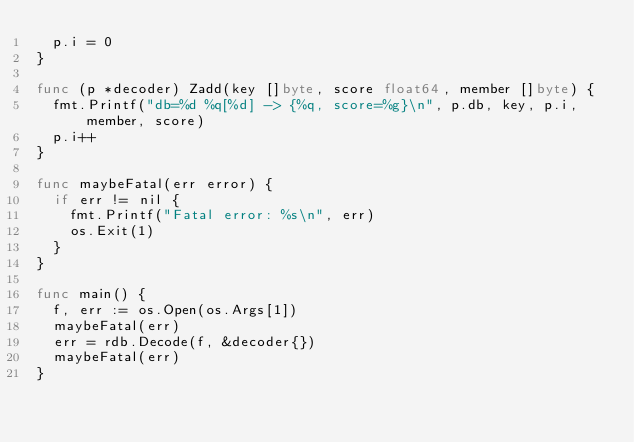Convert code to text. <code><loc_0><loc_0><loc_500><loc_500><_Go_>	p.i = 0
}

func (p *decoder) Zadd(key []byte, score float64, member []byte) {
	fmt.Printf("db=%d %q[%d] -> {%q, score=%g}\n", p.db, key, p.i, member, score)
	p.i++
}

func maybeFatal(err error) {
	if err != nil {
		fmt.Printf("Fatal error: %s\n", err)
		os.Exit(1)
	}
}

func main() {
	f, err := os.Open(os.Args[1])
	maybeFatal(err)
	err = rdb.Decode(f, &decoder{})
	maybeFatal(err)
}
</code> 